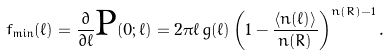<formula> <loc_0><loc_0><loc_500><loc_500>f _ { \min } ( \ell ) = \frac { \partial } { \partial \ell } \text {P} ( 0 ; \ell ) = 2 \pi \ell \, g ( \ell ) \left ( 1 - \frac { \langle n ( \ell ) \rangle } { n ( R ) } \right ) ^ { n ( R ) - 1 } .</formula> 